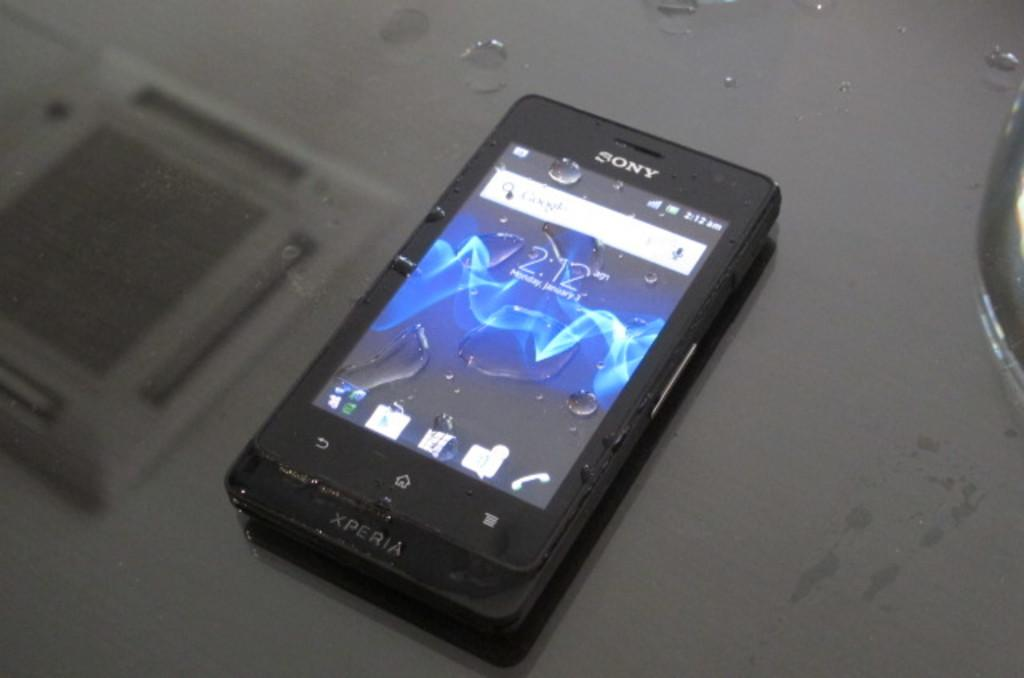<image>
Provide a brief description of the given image. The time is 2:12 in the morning according to this XPERIA smartphone. 